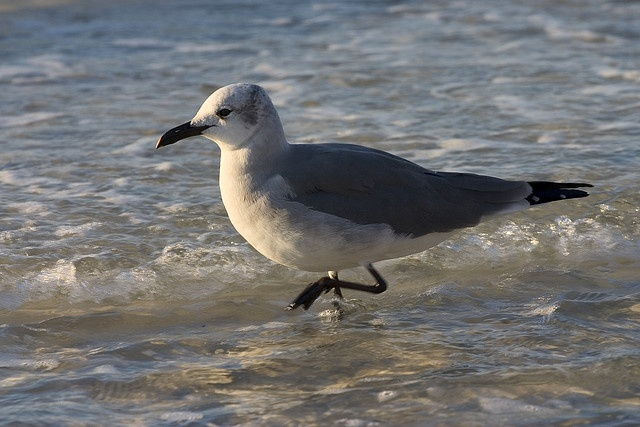Describe the objects in this image and their specific colors. I can see a bird in gray, black, darkgray, and tan tones in this image. 